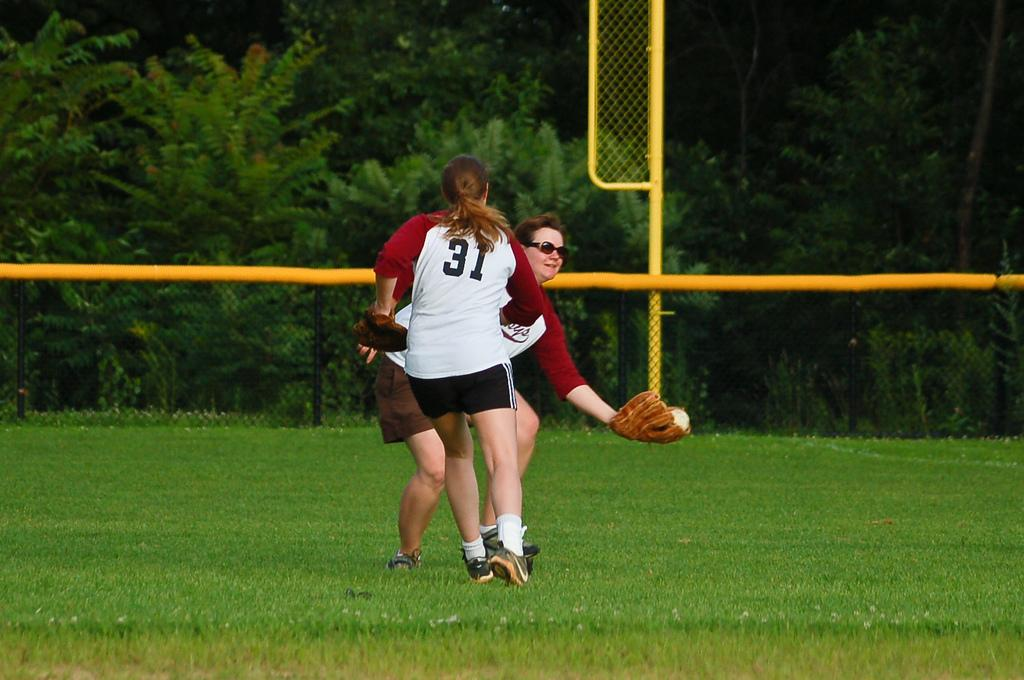<image>
Share a concise interpretation of the image provided. A person wearing a number 31 jersey stands in front of someone wearing a catcher's mitt. 